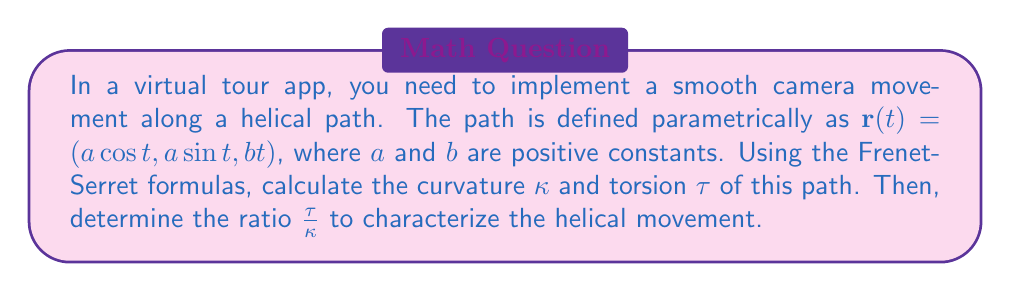Can you solve this math problem? 1. First, we need to calculate $\mathbf{r}'(t)$, $\mathbf{r}''(t)$, and $\mathbf{r}'''(t)$:

   $\mathbf{r}'(t) = (-a\sin t, a\cos t, b)$
   $\mathbf{r}''(t) = (-a\cos t, -a\sin t, 0)$
   $\mathbf{r}'''(t) = (a\sin t, -a\cos t, 0)$

2. Calculate the speed $\|\mathbf{r}'(t)\|$:
   
   $\|\mathbf{r}'(t)\| = \sqrt{(-a\sin t)^2 + (a\cos t)^2 + b^2} = \sqrt{a^2 + b^2}$

3. Calculate the curvature $\kappa$:

   $$\kappa = \frac{\|\mathbf{r}'(t) \times \mathbf{r}''(t)\|}{\|\mathbf{r}'(t)\|^3}$$

   $\mathbf{r}'(t) \times \mathbf{r}''(t) = (ab\sin t, -ab\cos t, a^2)$
   
   $\|\mathbf{r}'(t) \times \mathbf{r}''(t)\| = \sqrt{(ab\sin t)^2 + (-ab\cos t)^2 + (a^2)^2} = a\sqrt{a^2 + b^2}$

   $$\kappa = \frac{a\sqrt{a^2 + b^2}}{(a^2 + b^2)^{3/2}} = \frac{a}{a^2 + b^2}$$

4. Calculate the torsion $\tau$:

   $$\tau = \frac{(\mathbf{r}'(t) \times \mathbf{r}''(t)) \cdot \mathbf{r}'''(t)}{\|\mathbf{r}'(t) \times \mathbf{r}''(t)\|^2}$$

   $(\mathbf{r}'(t) \times \mathbf{r}''(t)) \cdot \mathbf{r}'''(t) = (ab\sin t, -ab\cos t, a^2) \cdot (a\sin t, -a\cos t, 0) = ab^2$

   $$\tau = \frac{ab^2}{a^2(a^2 + b^2)} = \frac{b^2}{a(a^2 + b^2)}$$

5. Calculate the ratio $\frac{\tau}{\kappa}$:

   $$\frac{\tau}{\kappa} = \frac{b^2}{a(a^2 + b^2)} \cdot \frac{a^2 + b^2}{a} = \frac{b^2}{a^2}$$

This ratio characterizes the helical movement of the camera in the virtual tour app.
Answer: $\kappa = \frac{a}{a^2 + b^2}$, $\tau = \frac{b^2}{a(a^2 + b^2)}$, $\frac{\tau}{\kappa} = \frac{b^2}{a^2}$ 